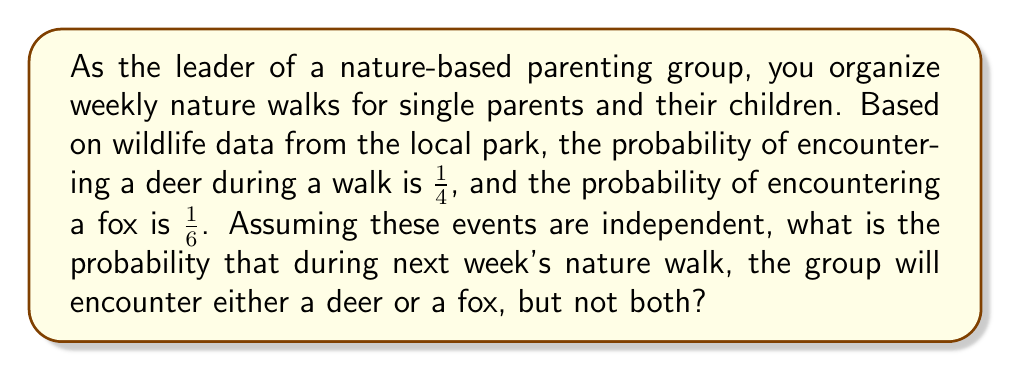Provide a solution to this math problem. To solve this problem, we'll use the concept of mutually exclusive events and the addition rule of probability.

Let's define our events:
$D$: Encountering a deer
$F$: Encountering a fox

We're given:
$P(D) = \frac{1}{4}$
$P(F) = \frac{1}{6}$

We want to find $P(D \text{ or } F \text{, but not both})$. This can be expressed as:

$P((D \text{ and not } F) \text{ or } (F \text{ and not } D))$

Since these are mutually exclusive events, we can add their probabilities:

$P((D \text{ and not } F) \text{ or } (F \text{ and not } D)) = P(D \text{ and not } F) + P(F \text{ and not } D)$

Now, let's calculate each part:

1) $P(D \text{ and not } F) = P(D) \cdot P(\text{not } F) = \frac{1}{4} \cdot (1 - \frac{1}{6}) = \frac{1}{4} \cdot \frac{5}{6} = \frac{5}{24}$

2) $P(F \text{ and not } D) = P(F) \cdot P(\text{not } D) = \frac{1}{6} \cdot (1 - \frac{1}{4}) = \frac{1}{6} \cdot \frac{3}{4} = \frac{1}{8}$

Now, we can add these probabilities:

$P((D \text{ and not } F) \text{ or } (F \text{ and not } D)) = \frac{5}{24} + \frac{1}{8} = \frac{5}{24} + \frac{3}{24} = \frac{8}{24} = \frac{1}{3}$
Answer: The probability that the group will encounter either a deer or a fox, but not both, during next week's nature walk is $\frac{1}{3}$ or approximately $0.3333$ or $33.33\%$. 